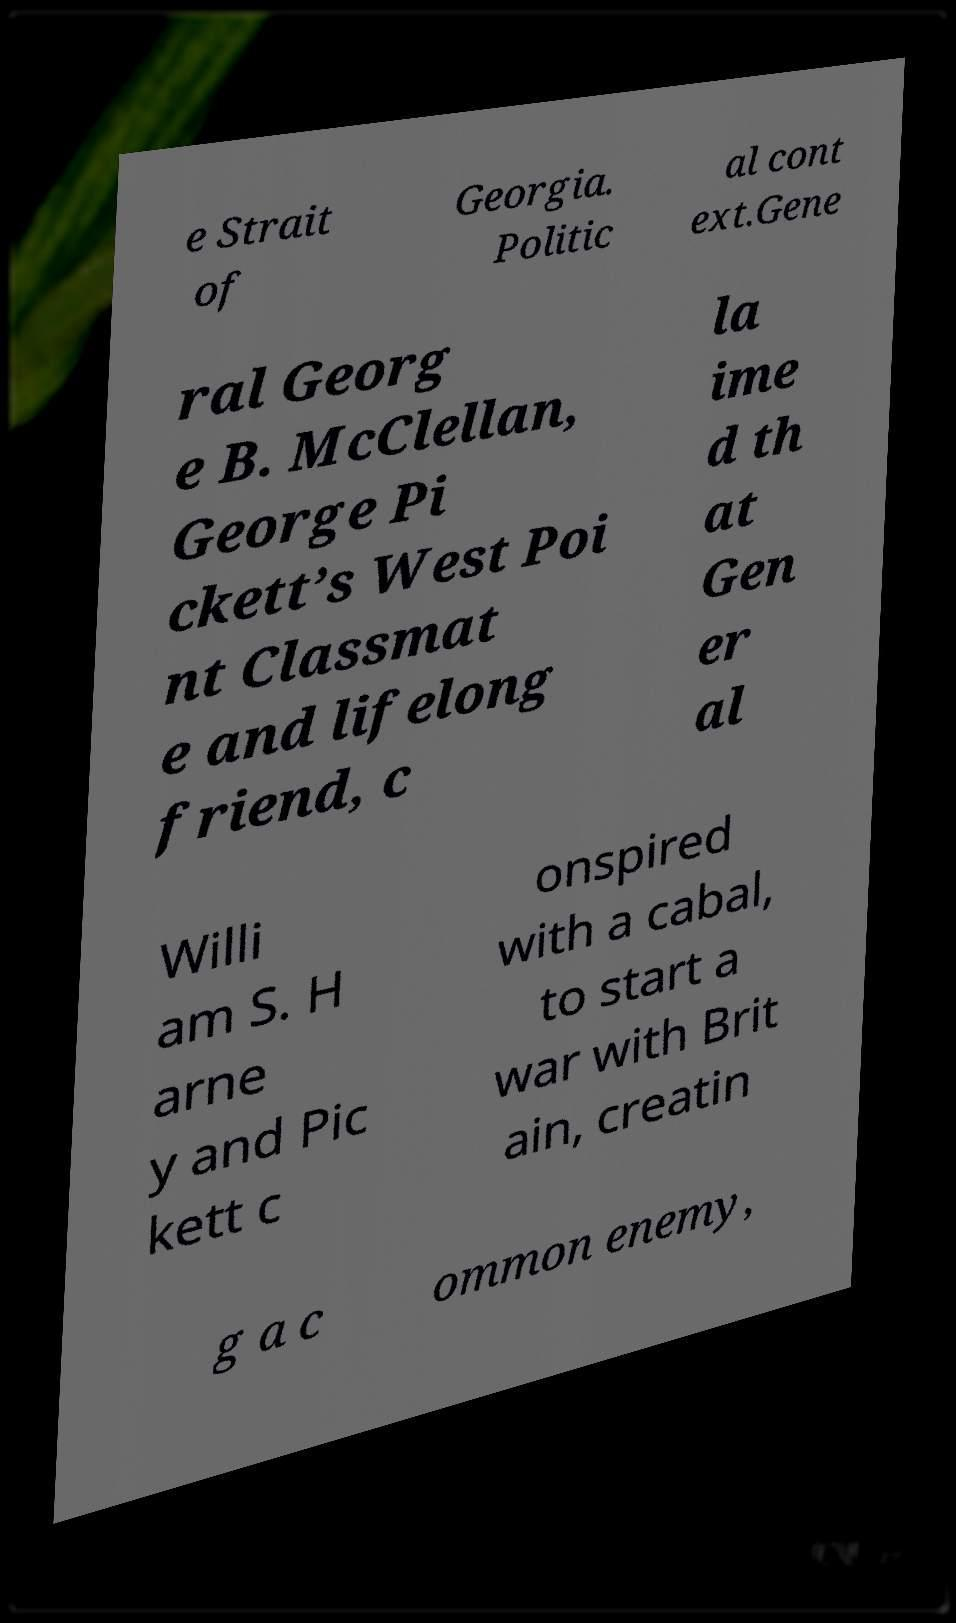Could you assist in decoding the text presented in this image and type it out clearly? e Strait of Georgia. Politic al cont ext.Gene ral Georg e B. McClellan, George Pi ckett’s West Poi nt Classmat e and lifelong friend, c la ime d th at Gen er al Willi am S. H arne y and Pic kett c onspired with a cabal, to start a war with Brit ain, creatin g a c ommon enemy, 